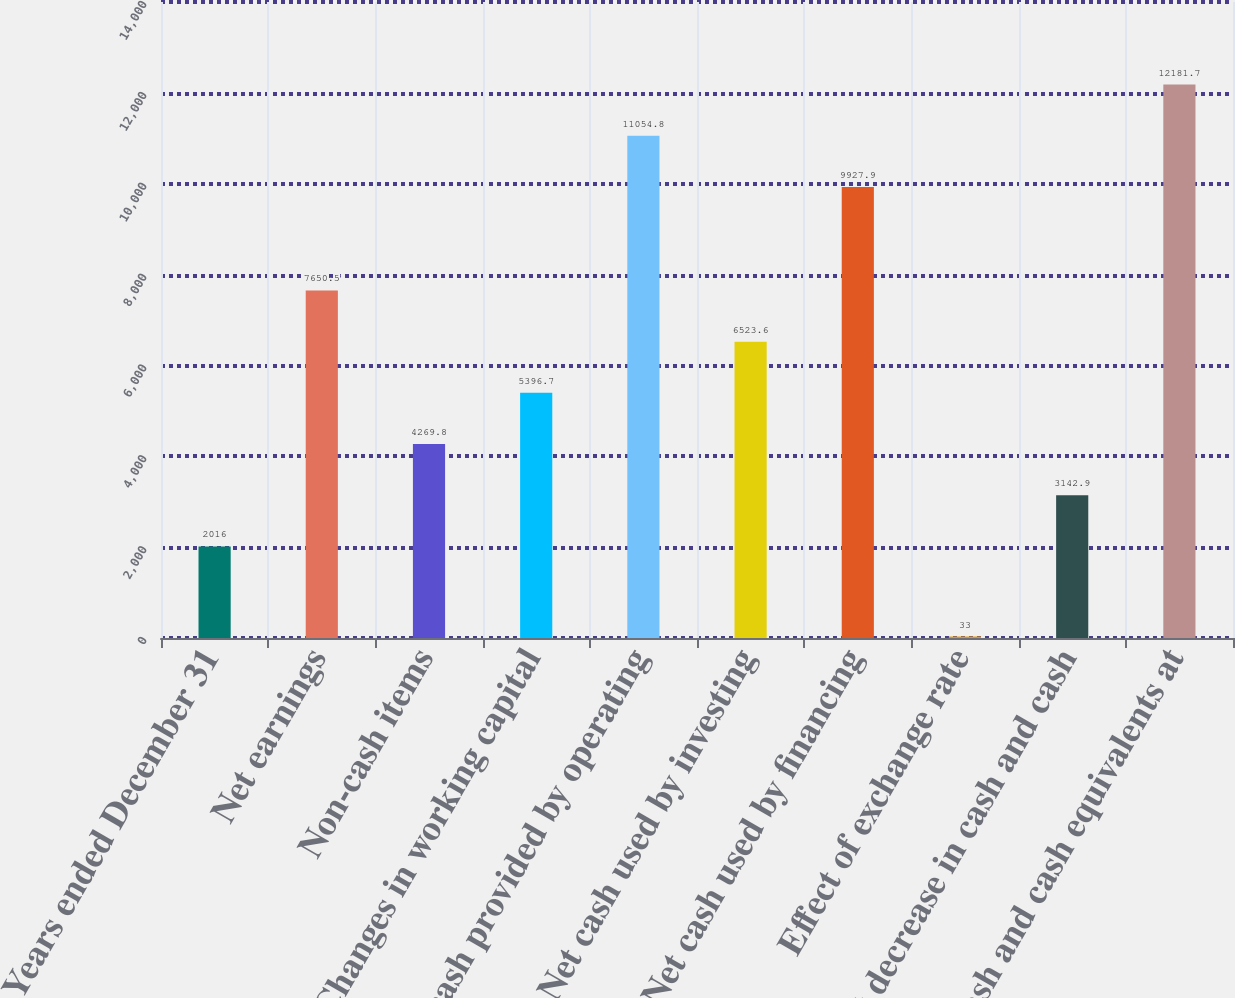Convert chart. <chart><loc_0><loc_0><loc_500><loc_500><bar_chart><fcel>Years ended December 31<fcel>Net earnings<fcel>Non-cash items<fcel>Changes in working capital<fcel>Net cash provided by operating<fcel>Net cash used by investing<fcel>Net cash used by financing<fcel>Effect of exchange rate<fcel>Net decrease in cash and cash<fcel>Cash and cash equivalents at<nl><fcel>2016<fcel>7650.5<fcel>4269.8<fcel>5396.7<fcel>11054.8<fcel>6523.6<fcel>9927.9<fcel>33<fcel>3142.9<fcel>12181.7<nl></chart> 